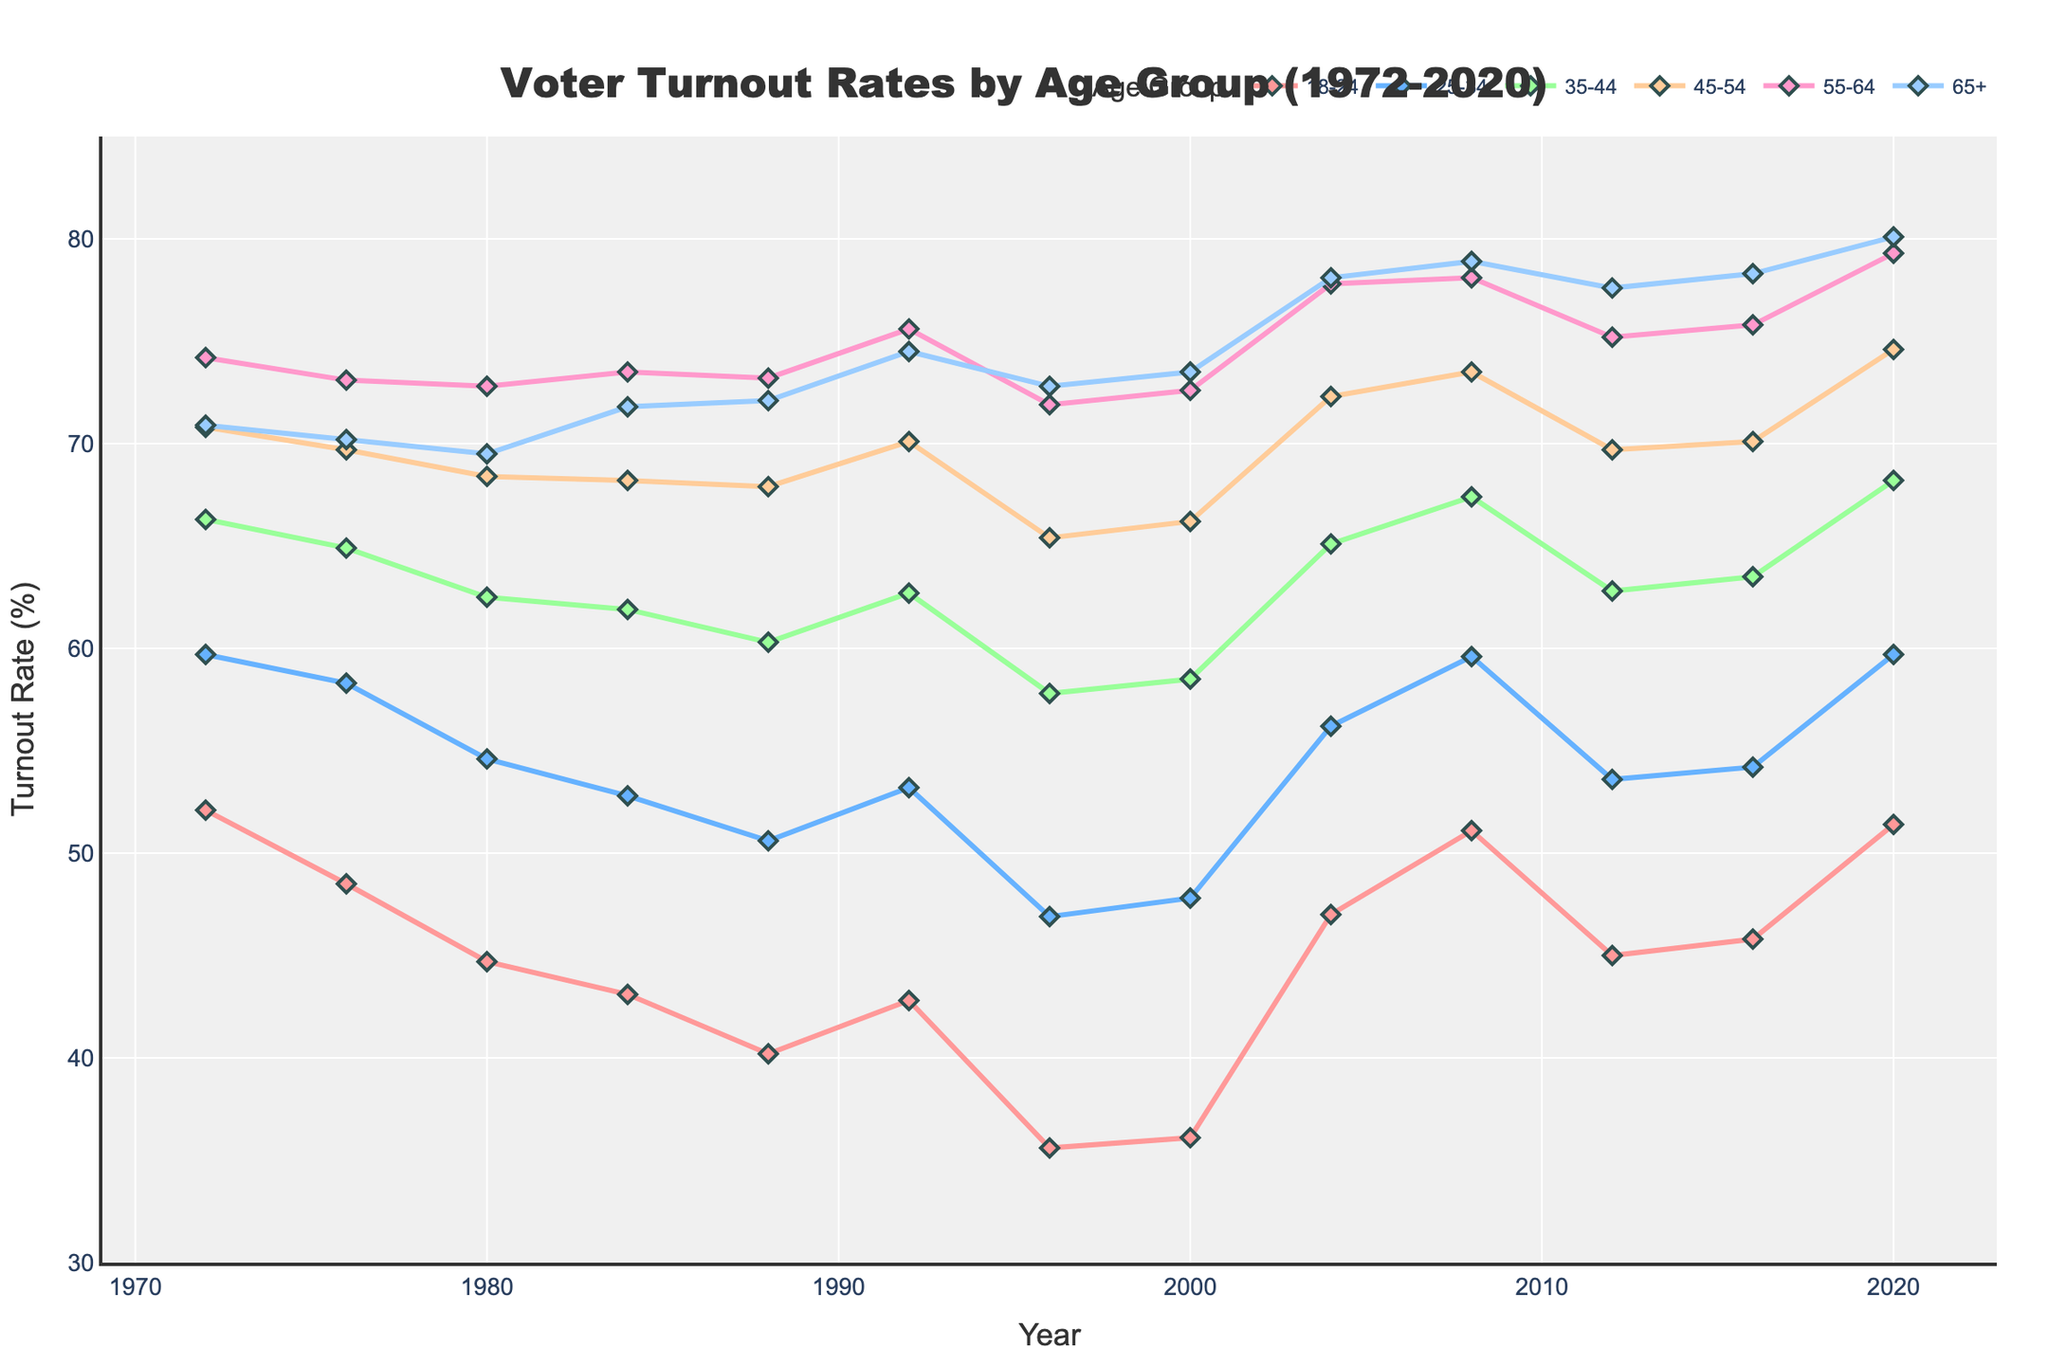What age group had the lowest voter turnout rate in 1972 and what was the rate? The figure shows voter turnout rates for different age groups in 1972. By looking at the 1972 data points, the 18-24 age group had the lowest turnout rate.
Answer: 18-24, 52.1% How did voter turnout for the 25-34 age group change from 1980 to 1984? The figure has voter turnout percentages for each year. The 25-34 age group had a turnout of 54.6% in 1980 and 52.8% in 1984. The change is 54.6% - 52.8% = 1.8% decrease.
Answer: 1.8% decrease Which age group experienced the highest increase in voter turnout between 2016 and 2020? By observing the 2016 and 2020 data points for each age group, the 18-24 age group increased from 45.8% to 51.4%, making a 5.6% increase, which is the highest among all age groups.
Answer: 18-24 What was the voter turnout rate for the 65+ age group in 1996? The figure shows different turnout rates, and looking directly at the 65+ line for the year 1996 gives 72.8%.
Answer: 72.8% In which year did the 35-44 age group see the largest voter turnout rate? Review the peaks of the 35-44 line. The highest point is in 2020 with a turnout rate of 68.2%.
Answer: 2020 What was the average voter turnout rate for the 55-64 age group over the 50 years? Add all turnout rates for the 55-64 age group from each year and divide by the number of years (12). (74.2 + 73.1 + 72.8 + 73.5 + 73.2 + 75.6 + 71.9 + 72.6 + 77.8 + 78.1 + 75.2 + 75.8 + 79.3) / 13 = 74.69
Answer: 74.7% Which year had the largest turnout rate difference between the 18-24 and 65+ age groups? For each year, calculate the difference between the 18-24 and 65+ voter turnout rates. 2020 shows the largest difference: 80.1% - 51.4% = 28.7%.
Answer: 2020 Between any two consecutive decades, which age group showed the most consistent voter turnout rates? Visually assess and compare the lines. The 65+ age group maintains the most consistent levels through the decades.
Answer: 65+ How did the voter turnout for the 45-54 age group change from the first to the last decade? Compare the figures from the beginning (1970s) and end (2010s). In 1972, the rate was 70.8%, and 2020 was 74.6%. The change is 74.6% - 70.8% = 3.8% increase.
Answer: 3.8% increase Is there a noticeable trend in the voter turnout rates for the 18-24 age group over the 50 years? Visually, the 18-24 age group line shows fluctuations with a long-term slight decline from 52.1% in 1972 to a low, then eventually rising to 51.4% in 2020.
Answer: Fluctuating trends, almost returning to initial rate 